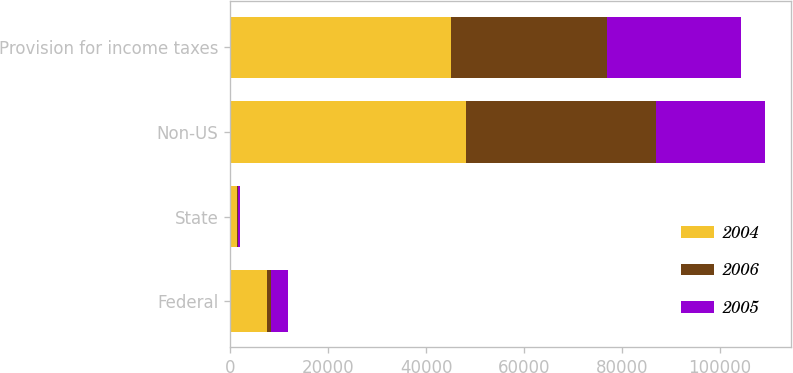Convert chart to OTSL. <chart><loc_0><loc_0><loc_500><loc_500><stacked_bar_chart><ecel><fcel>Federal<fcel>State<fcel>Non-US<fcel>Provision for income taxes<nl><fcel>2004<fcel>7507<fcel>1370<fcel>48221<fcel>45183<nl><fcel>2006<fcel>799<fcel>246<fcel>38793<fcel>31841<nl><fcel>2005<fcel>3567<fcel>372<fcel>22186<fcel>27384<nl></chart> 